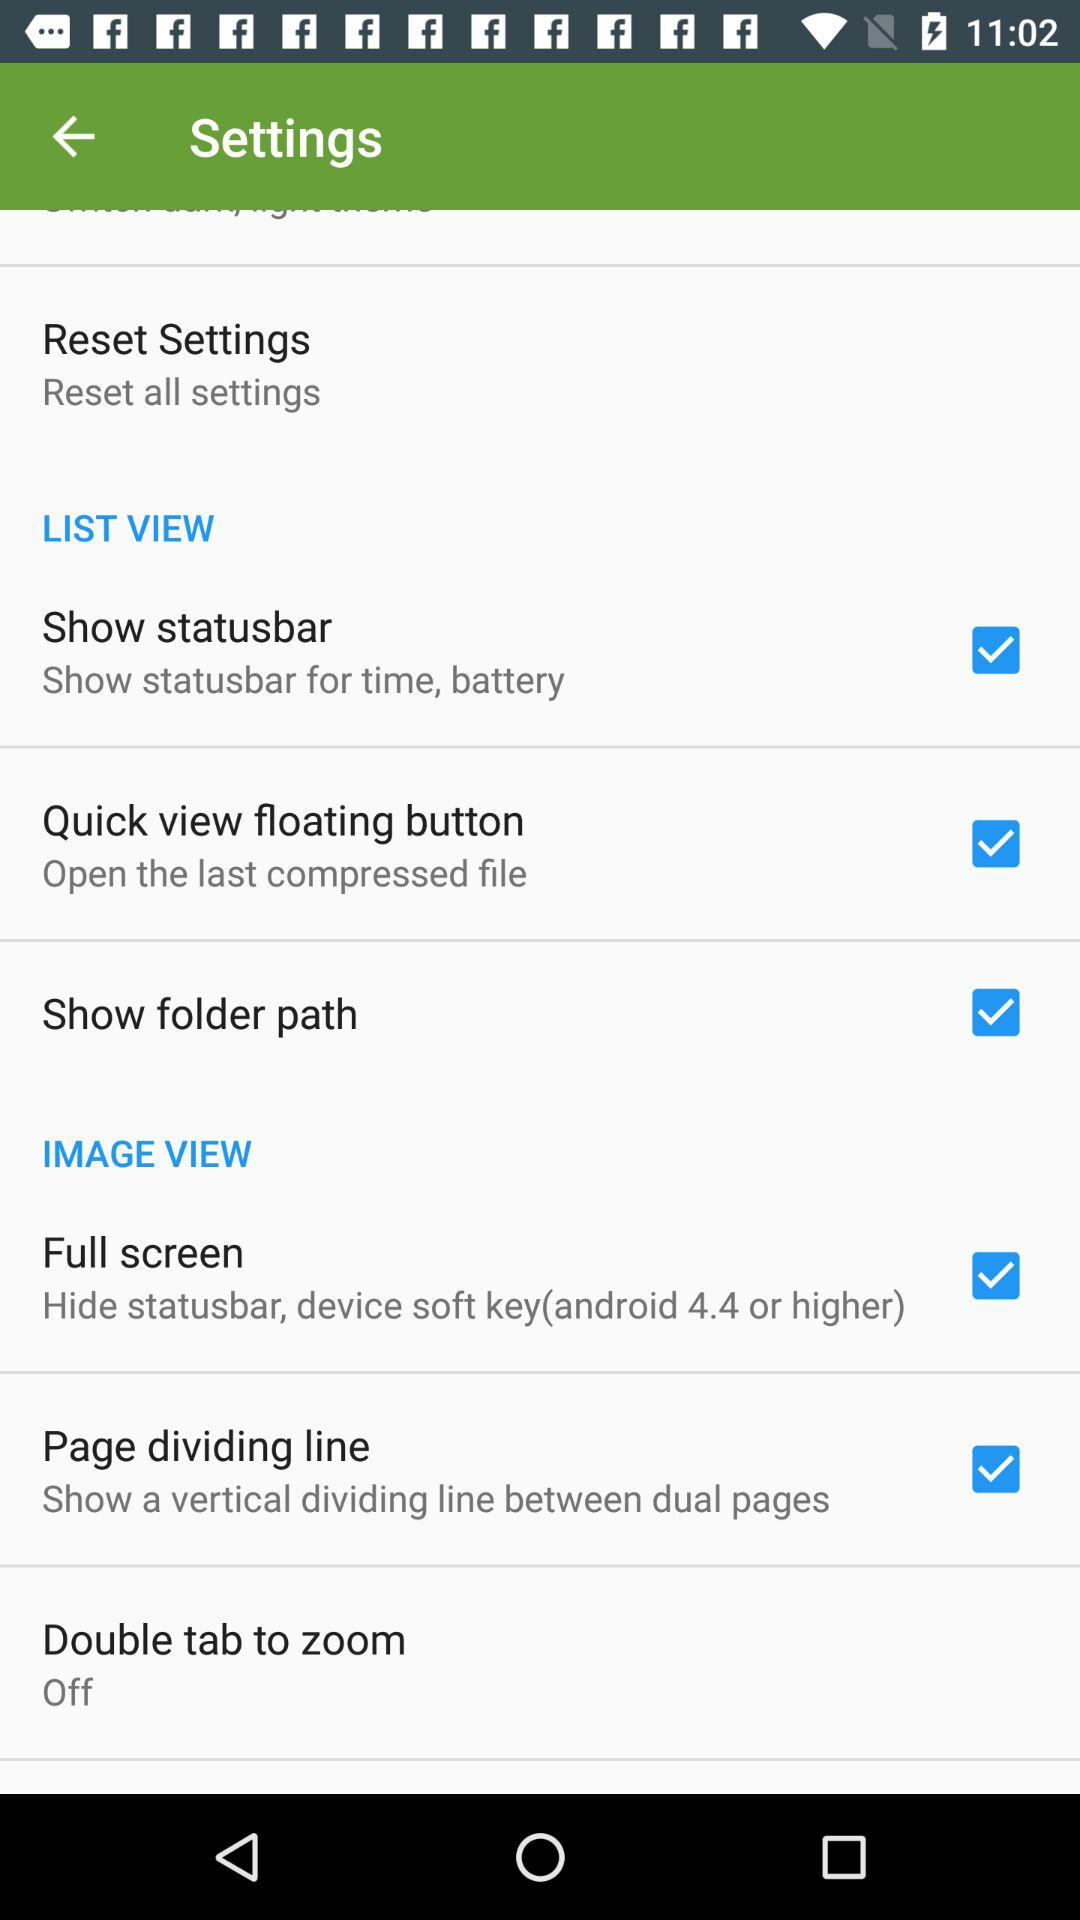Which settings are marked as checked under the List View settings? The settings that are marked as checked under the List View settings are "Show statusbar", "Quick view floating button" and "Show folder path". 